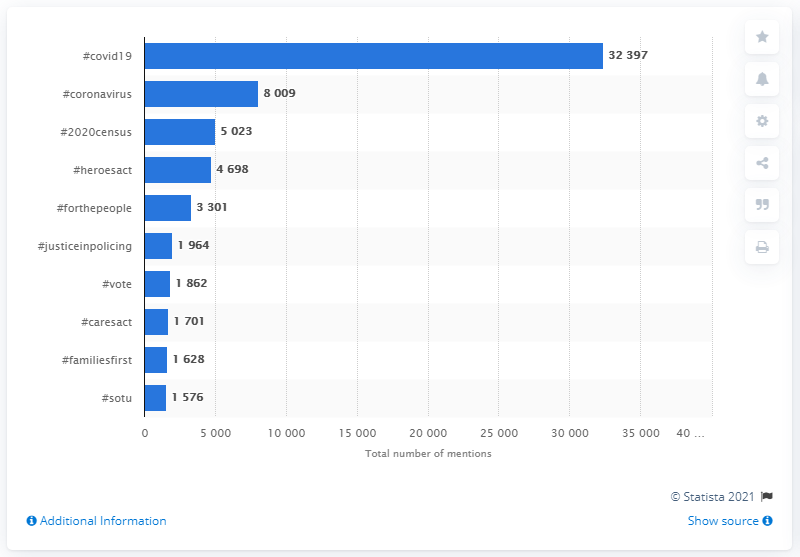Draw attention to some important aspects in this diagram. In 2020, the most popular hashtag used by Democratic members of Congress was #covid19, which refers to the COVID-19 pandemic. 